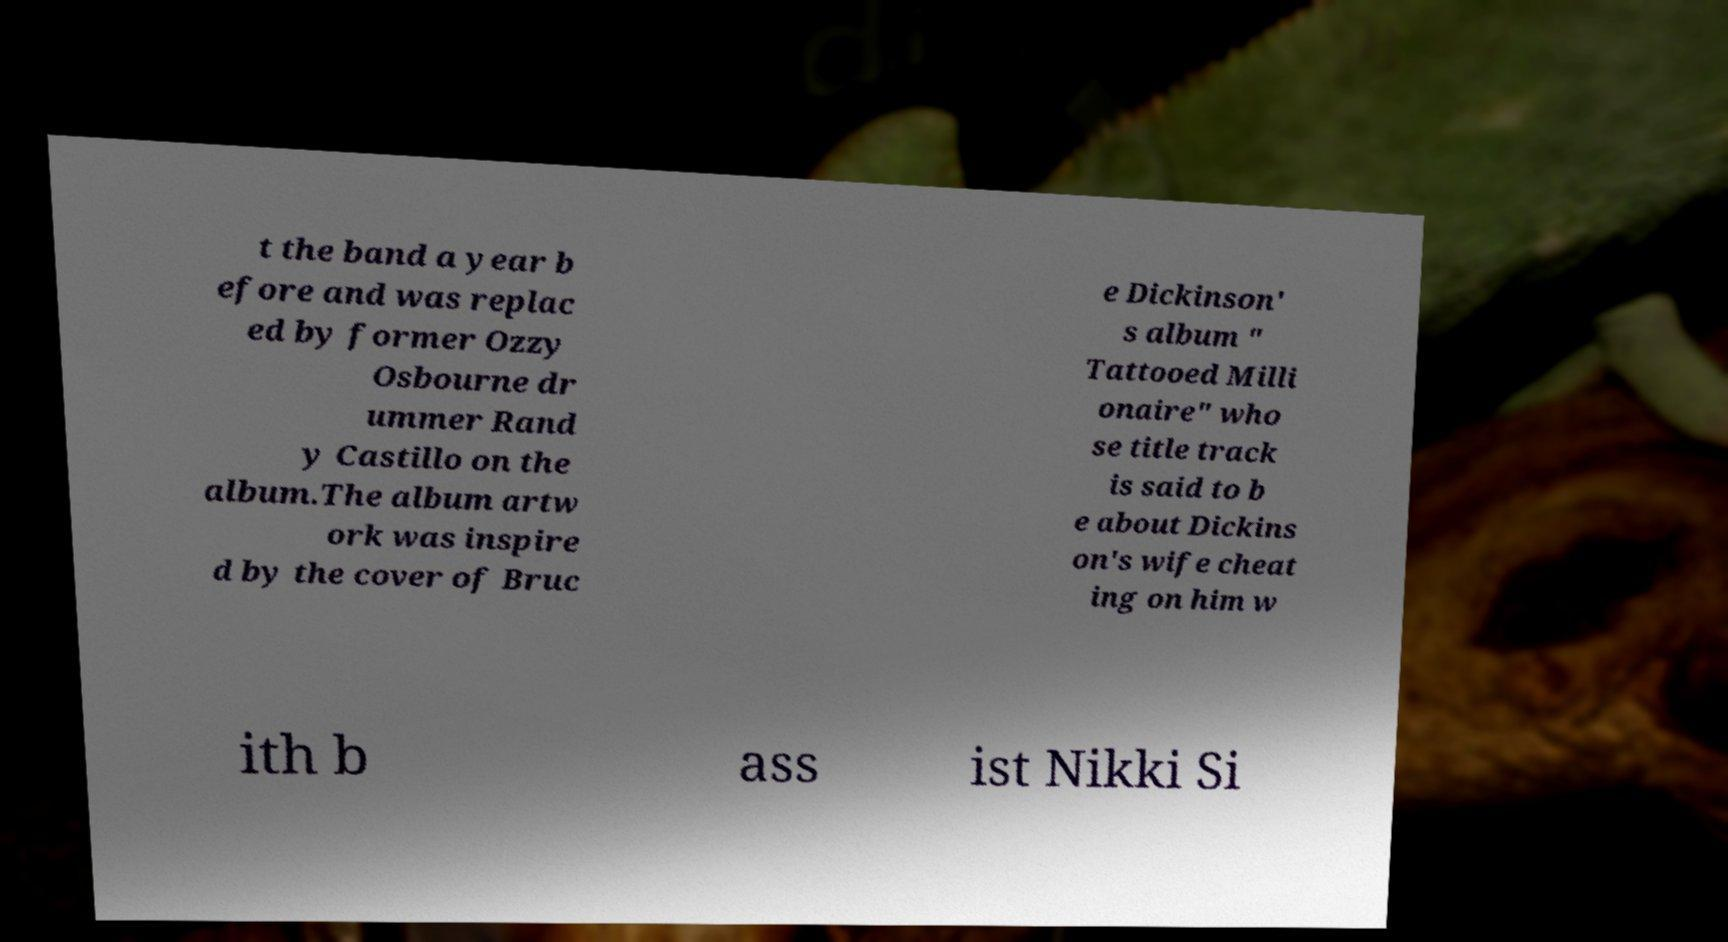Can you read and provide the text displayed in the image?This photo seems to have some interesting text. Can you extract and type it out for me? t the band a year b efore and was replac ed by former Ozzy Osbourne dr ummer Rand y Castillo on the album.The album artw ork was inspire d by the cover of Bruc e Dickinson' s album " Tattooed Milli onaire" who se title track is said to b e about Dickins on's wife cheat ing on him w ith b ass ist Nikki Si 